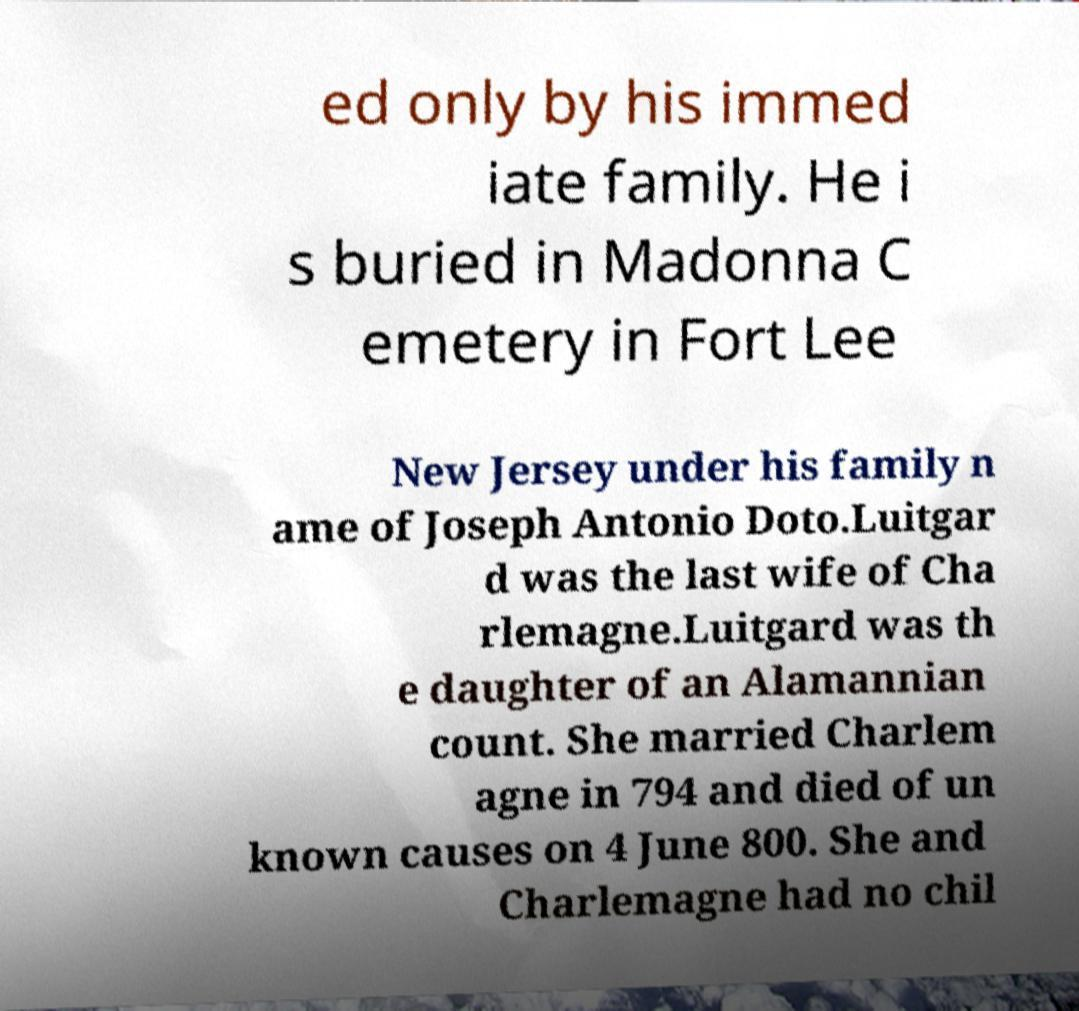There's text embedded in this image that I need extracted. Can you transcribe it verbatim? ed only by his immed iate family. He i s buried in Madonna C emetery in Fort Lee New Jersey under his family n ame of Joseph Antonio Doto.Luitgar d was the last wife of Cha rlemagne.Luitgard was th e daughter of an Alamannian count. She married Charlem agne in 794 and died of un known causes on 4 June 800. She and Charlemagne had no chil 